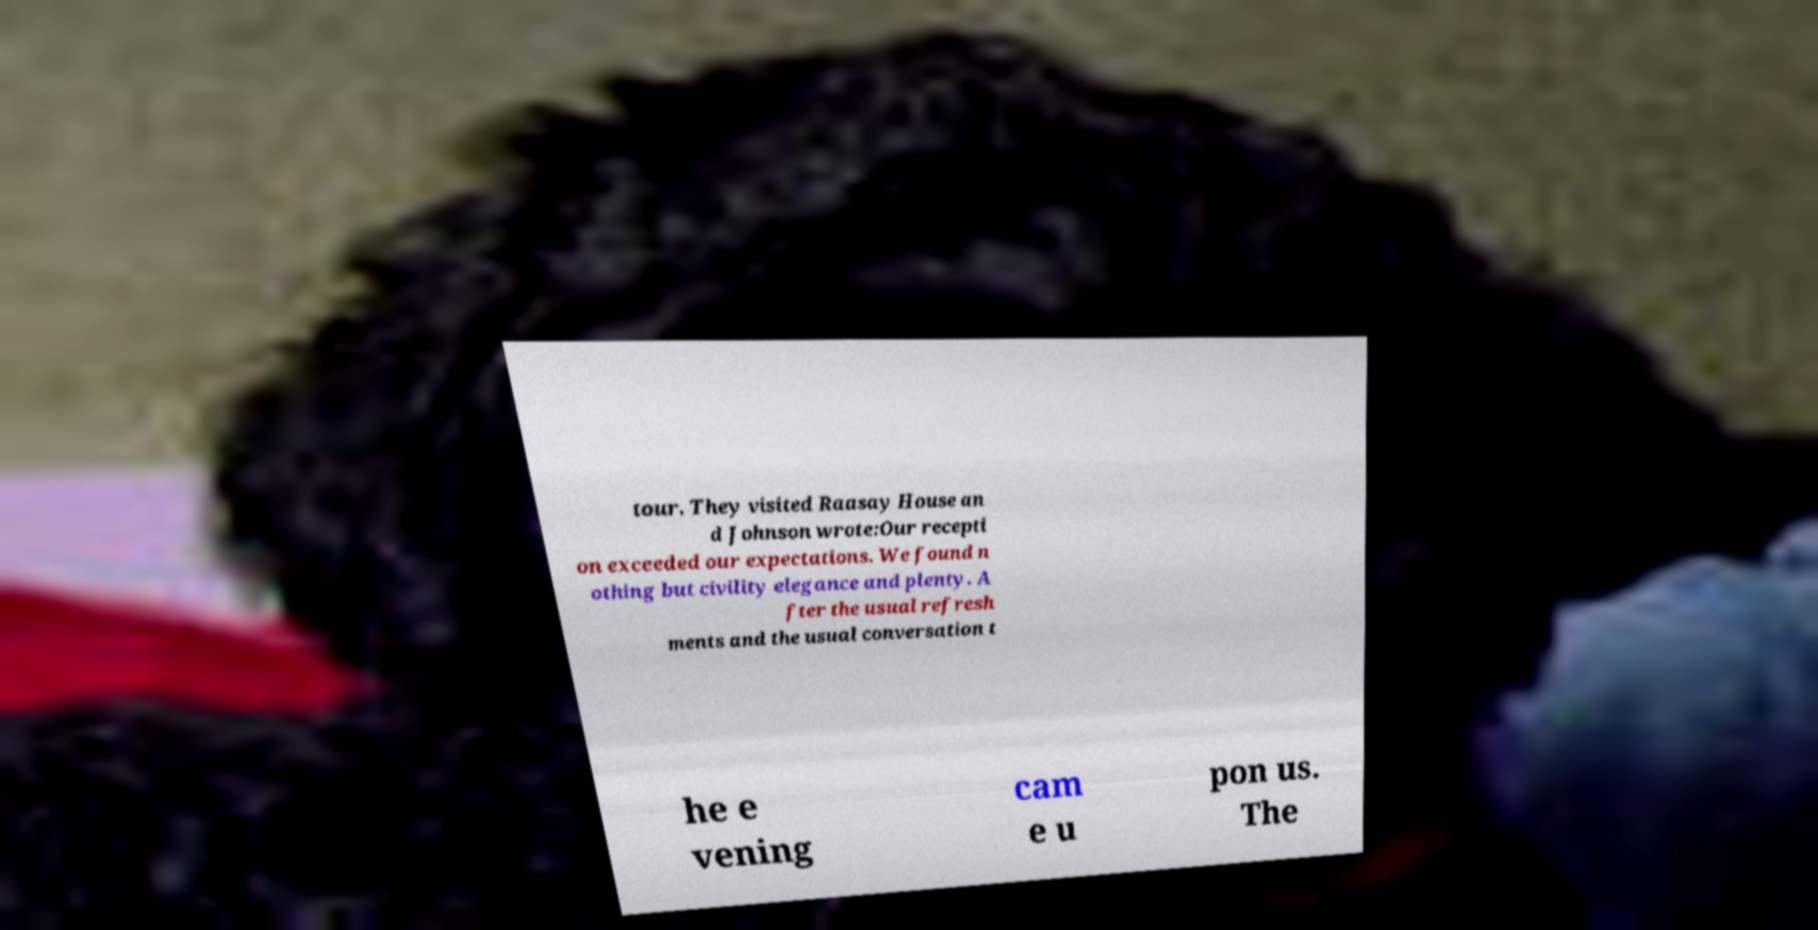There's text embedded in this image that I need extracted. Can you transcribe it verbatim? tour. They visited Raasay House an d Johnson wrote:Our recepti on exceeded our expectations. We found n othing but civility elegance and plenty. A fter the usual refresh ments and the usual conversation t he e vening cam e u pon us. The 